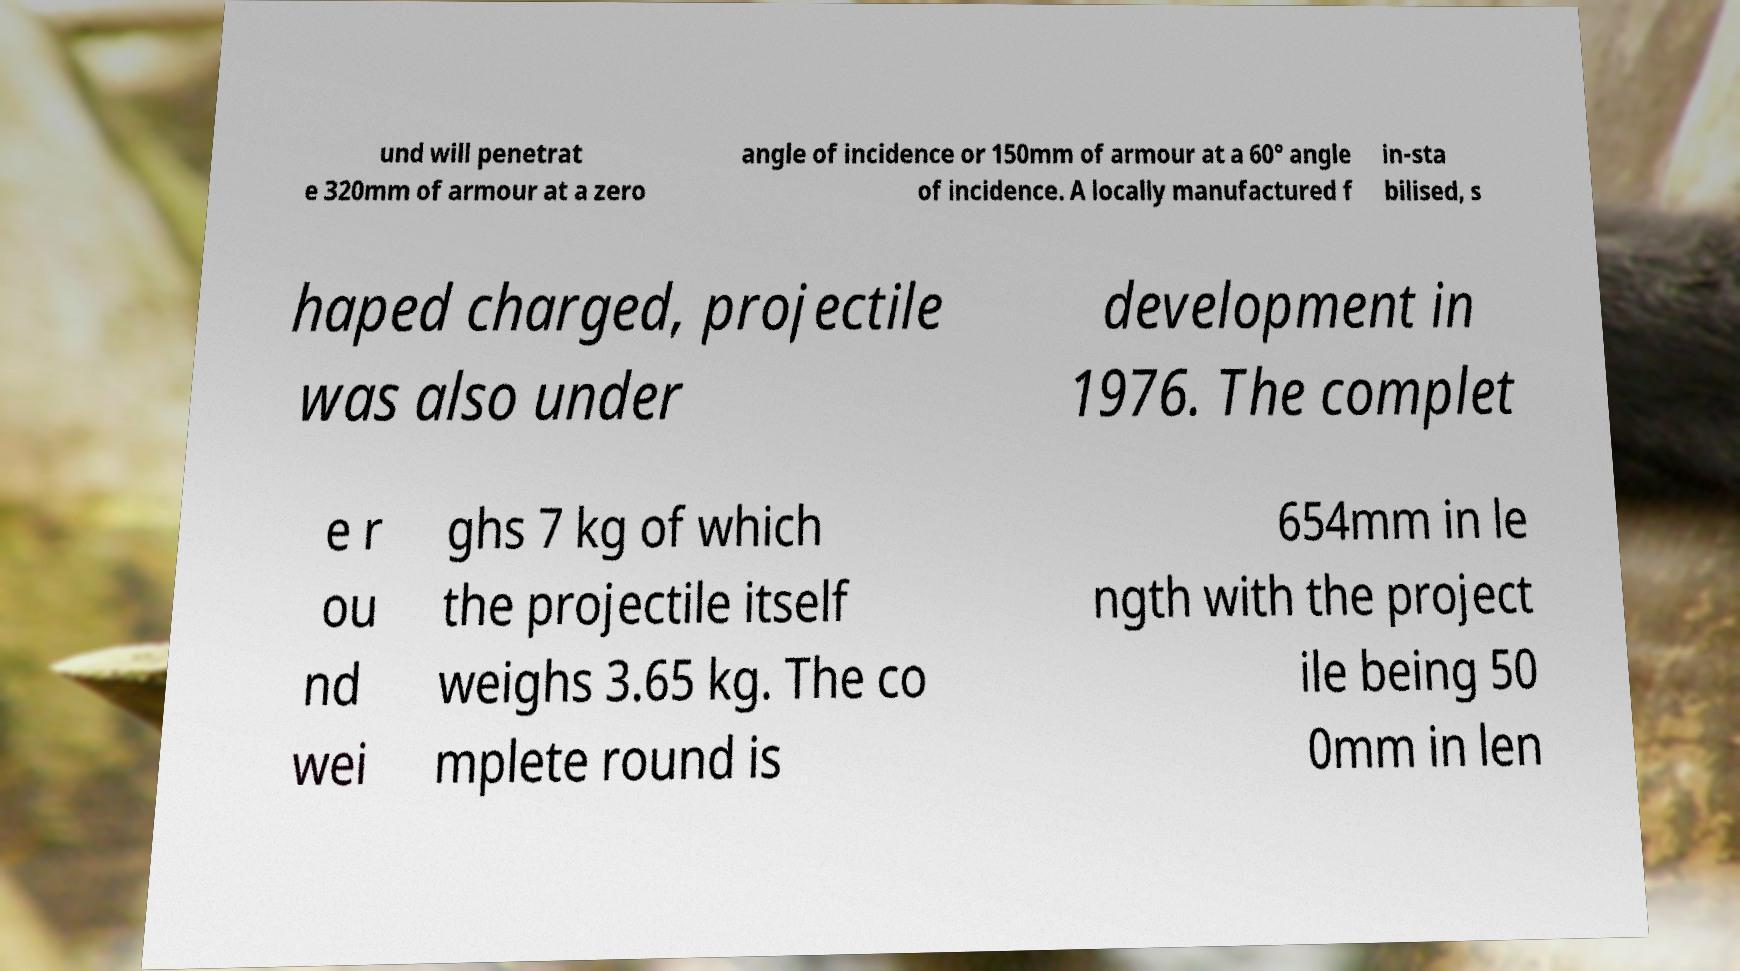Can you read and provide the text displayed in the image?This photo seems to have some interesting text. Can you extract and type it out for me? und will penetrat e 320mm of armour at a zero angle of incidence or 150mm of armour at a 60° angle of incidence. A locally manufactured f in-sta bilised, s haped charged, projectile was also under development in 1976. The complet e r ou nd wei ghs 7 kg of which the projectile itself weighs 3.65 kg. The co mplete round is 654mm in le ngth with the project ile being 50 0mm in len 